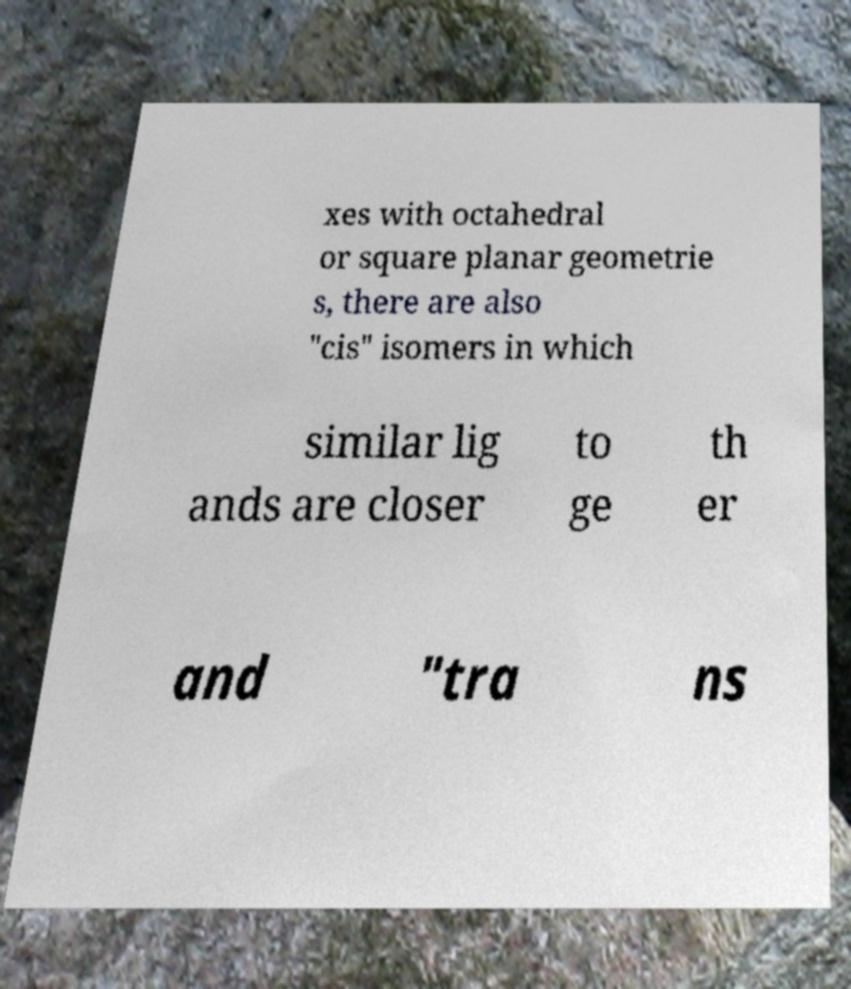I need the written content from this picture converted into text. Can you do that? xes with octahedral or square planar geometrie s, there are also "cis" isomers in which similar lig ands are closer to ge th er and "tra ns 